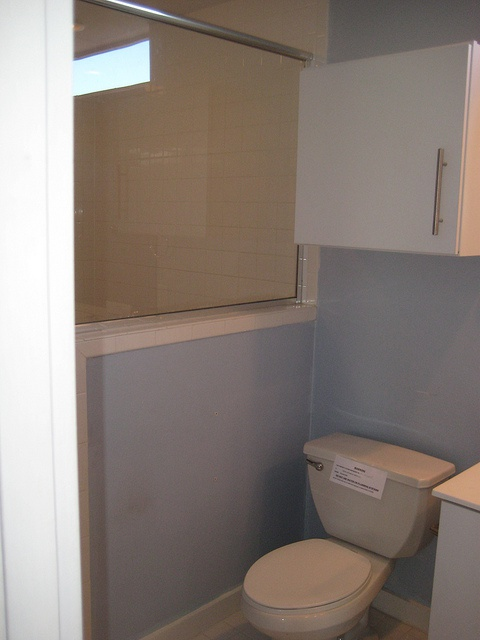Describe the objects in this image and their specific colors. I can see toilet in lightgray, gray, and black tones and sink in lightgray, tan, and gray tones in this image. 